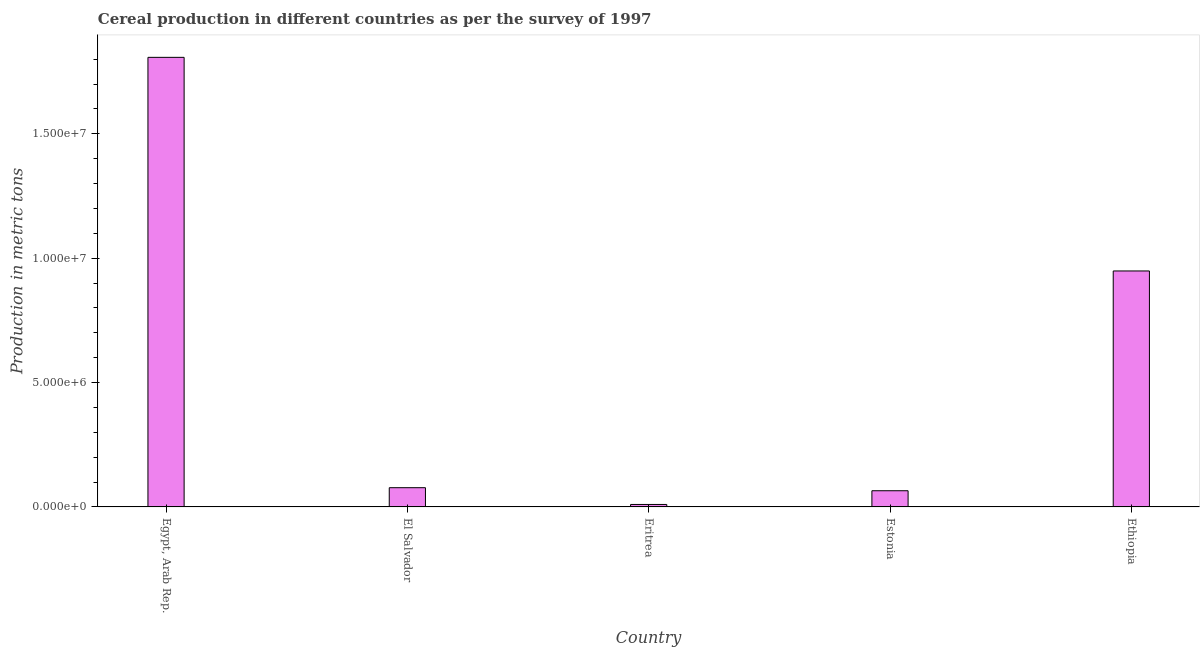Does the graph contain any zero values?
Offer a very short reply. No. Does the graph contain grids?
Offer a very short reply. No. What is the title of the graph?
Give a very brief answer. Cereal production in different countries as per the survey of 1997. What is the label or title of the Y-axis?
Offer a terse response. Production in metric tons. What is the cereal production in Eritrea?
Give a very brief answer. 9.94e+04. Across all countries, what is the maximum cereal production?
Your answer should be very brief. 1.81e+07. Across all countries, what is the minimum cereal production?
Your answer should be very brief. 9.94e+04. In which country was the cereal production maximum?
Make the answer very short. Egypt, Arab Rep. In which country was the cereal production minimum?
Your response must be concise. Eritrea. What is the sum of the cereal production?
Your response must be concise. 2.91e+07. What is the difference between the cereal production in El Salvador and Eritrea?
Keep it short and to the point. 6.74e+05. What is the average cereal production per country?
Provide a succinct answer. 5.82e+06. What is the median cereal production?
Make the answer very short. 7.73e+05. In how many countries, is the cereal production greater than 6000000 metric tons?
Your answer should be very brief. 2. What is the ratio of the cereal production in Eritrea to that in Ethiopia?
Your answer should be compact. 0.01. Is the difference between the cereal production in El Salvador and Ethiopia greater than the difference between any two countries?
Provide a short and direct response. No. What is the difference between the highest and the second highest cereal production?
Your response must be concise. 8.59e+06. What is the difference between the highest and the lowest cereal production?
Provide a short and direct response. 1.80e+07. In how many countries, is the cereal production greater than the average cereal production taken over all countries?
Your answer should be compact. 2. How many bars are there?
Provide a short and direct response. 5. Are all the bars in the graph horizontal?
Offer a terse response. No. How many countries are there in the graph?
Your answer should be very brief. 5. Are the values on the major ticks of Y-axis written in scientific E-notation?
Provide a short and direct response. Yes. What is the Production in metric tons of Egypt, Arab Rep.?
Give a very brief answer. 1.81e+07. What is the Production in metric tons in El Salvador?
Ensure brevity in your answer.  7.73e+05. What is the Production in metric tons of Eritrea?
Offer a very short reply. 9.94e+04. What is the Production in metric tons in Estonia?
Offer a very short reply. 6.51e+05. What is the Production in metric tons of Ethiopia?
Keep it short and to the point. 9.48e+06. What is the difference between the Production in metric tons in Egypt, Arab Rep. and El Salvador?
Your answer should be very brief. 1.73e+07. What is the difference between the Production in metric tons in Egypt, Arab Rep. and Eritrea?
Make the answer very short. 1.80e+07. What is the difference between the Production in metric tons in Egypt, Arab Rep. and Estonia?
Your response must be concise. 1.74e+07. What is the difference between the Production in metric tons in Egypt, Arab Rep. and Ethiopia?
Your response must be concise. 8.59e+06. What is the difference between the Production in metric tons in El Salvador and Eritrea?
Your answer should be compact. 6.74e+05. What is the difference between the Production in metric tons in El Salvador and Estonia?
Ensure brevity in your answer.  1.23e+05. What is the difference between the Production in metric tons in El Salvador and Ethiopia?
Provide a short and direct response. -8.71e+06. What is the difference between the Production in metric tons in Eritrea and Estonia?
Ensure brevity in your answer.  -5.51e+05. What is the difference between the Production in metric tons in Eritrea and Ethiopia?
Provide a short and direct response. -9.39e+06. What is the difference between the Production in metric tons in Estonia and Ethiopia?
Your answer should be compact. -8.83e+06. What is the ratio of the Production in metric tons in Egypt, Arab Rep. to that in El Salvador?
Provide a succinct answer. 23.37. What is the ratio of the Production in metric tons in Egypt, Arab Rep. to that in Eritrea?
Your answer should be compact. 181.84. What is the ratio of the Production in metric tons in Egypt, Arab Rep. to that in Estonia?
Provide a succinct answer. 27.78. What is the ratio of the Production in metric tons in Egypt, Arab Rep. to that in Ethiopia?
Keep it short and to the point. 1.91. What is the ratio of the Production in metric tons in El Salvador to that in Eritrea?
Offer a terse response. 7.78. What is the ratio of the Production in metric tons in El Salvador to that in Estonia?
Your answer should be compact. 1.19. What is the ratio of the Production in metric tons in El Salvador to that in Ethiopia?
Make the answer very short. 0.08. What is the ratio of the Production in metric tons in Eritrea to that in Estonia?
Your response must be concise. 0.15. What is the ratio of the Production in metric tons in Estonia to that in Ethiopia?
Keep it short and to the point. 0.07. 